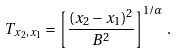<formula> <loc_0><loc_0><loc_500><loc_500>T _ { x _ { 2 } , x _ { 1 } } = \left [ \frac { ( x _ { 2 } - x _ { 1 } ) ^ { 2 } } { B ^ { 2 } } \right ] ^ { 1 / \alpha } \, .</formula> 